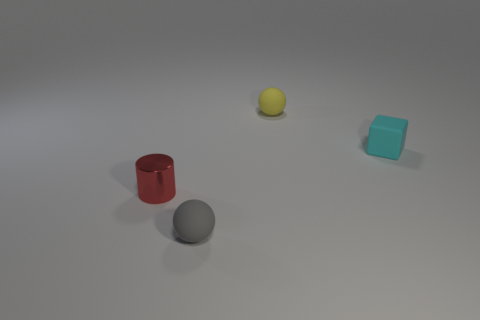Add 4 big purple rubber cylinders. How many objects exist? 8 Subtract 0 brown cylinders. How many objects are left? 4 Subtract all matte cubes. Subtract all yellow matte spheres. How many objects are left? 2 Add 4 small cyan blocks. How many small cyan blocks are left? 5 Add 4 tiny cyan blocks. How many tiny cyan blocks exist? 5 